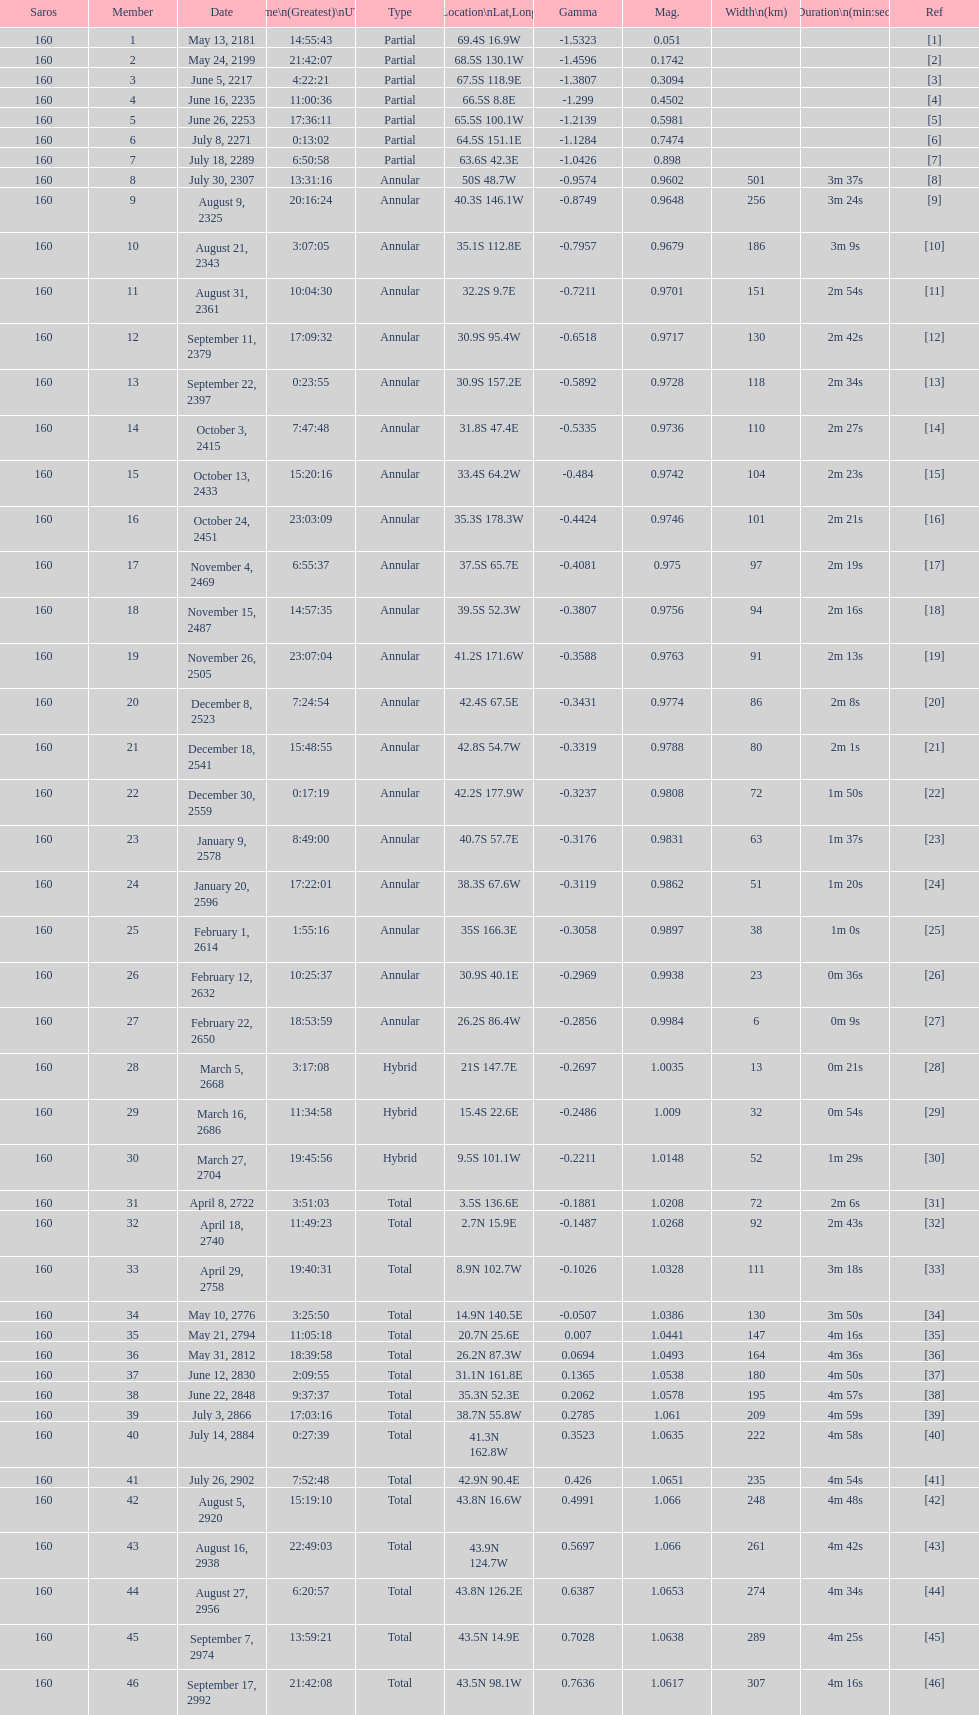What is the previous time for the saros on october 3, 2415? 7:47:48. 